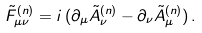<formula> <loc_0><loc_0><loc_500><loc_500>\tilde { F } ^ { ( n ) } _ { \mu \nu } = i \, ( \partial _ { \mu } \tilde { A } ^ { ( n ) } _ { \nu } - \partial _ { \nu } \tilde { A } ^ { ( n ) } _ { \mu } ) \, .</formula> 